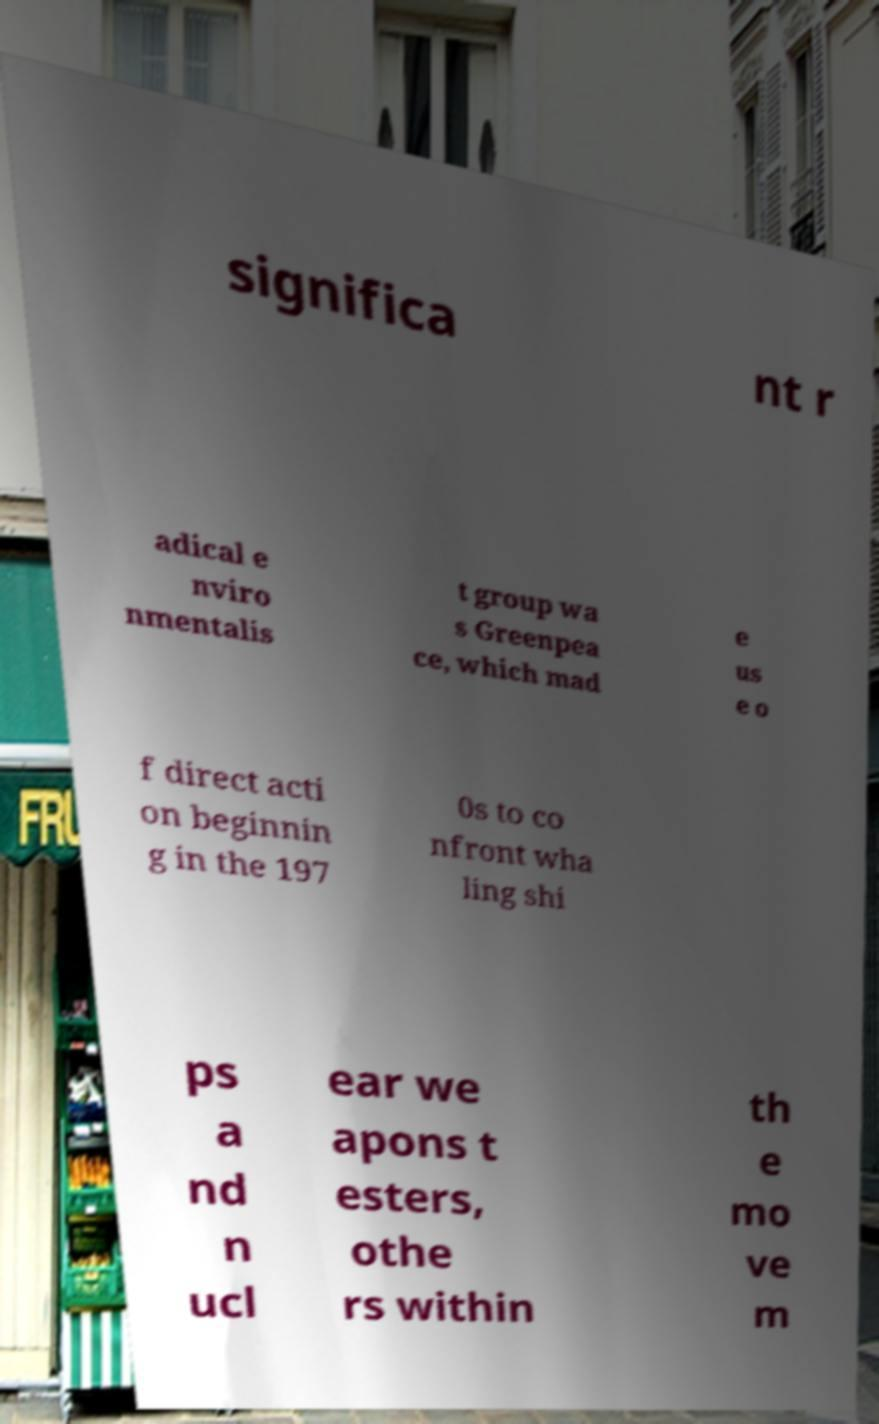Please read and relay the text visible in this image. What does it say? significa nt r adical e nviro nmentalis t group wa s Greenpea ce, which mad e us e o f direct acti on beginnin g in the 197 0s to co nfront wha ling shi ps a nd n ucl ear we apons t esters, othe rs within th e mo ve m 